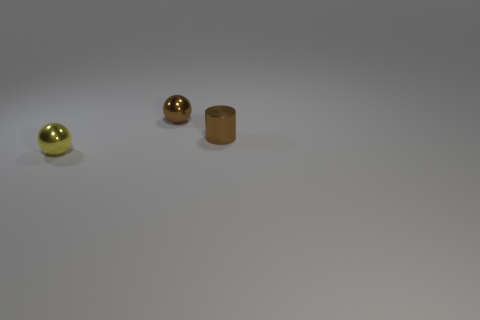Add 3 cyan shiny blocks. How many objects exist? 6 Subtract all cylinders. How many objects are left? 2 Subtract all brown spheres. Subtract all large rubber cylinders. How many objects are left? 2 Add 1 metal objects. How many metal objects are left? 4 Add 3 metal things. How many metal things exist? 6 Subtract 0 purple cylinders. How many objects are left? 3 